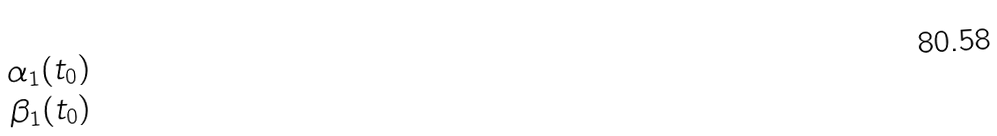Convert formula to latex. <formula><loc_0><loc_0><loc_500><loc_500>\begin{matrix} \alpha _ { 1 } ( t _ { 0 } ) \\ \beta _ { 1 } ( t _ { 0 } ) \end{matrix}</formula> 